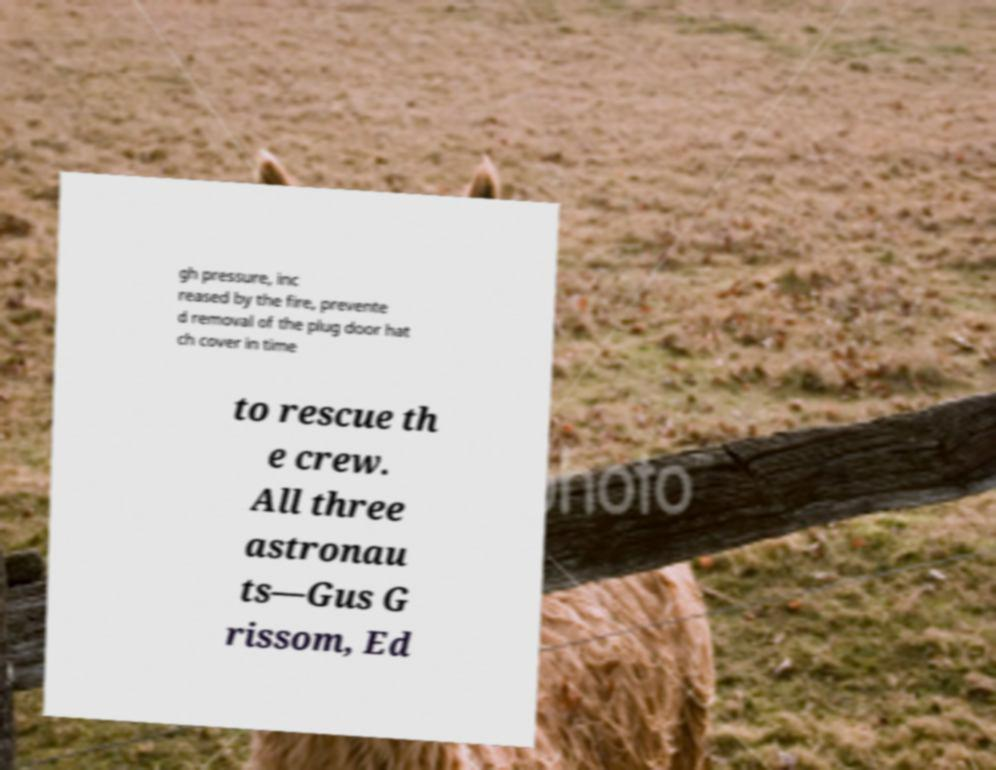Could you extract and type out the text from this image? gh pressure, inc reased by the fire, prevente d removal of the plug door hat ch cover in time to rescue th e crew. All three astronau ts—Gus G rissom, Ed 